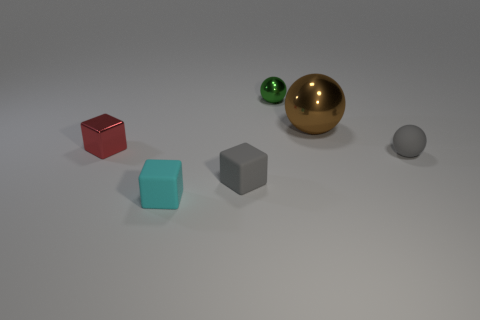Subtract all small cyan blocks. How many blocks are left? 2 Add 3 small gray blocks. How many objects exist? 9 Subtract 1 spheres. How many spheres are left? 2 Subtract all brown spheres. How many spheres are left? 2 Subtract all blue things. Subtract all green balls. How many objects are left? 5 Add 4 tiny cyan blocks. How many tiny cyan blocks are left? 5 Add 4 tiny gray spheres. How many tiny gray spheres exist? 5 Subtract 0 brown cubes. How many objects are left? 6 Subtract all yellow balls. Subtract all green cylinders. How many balls are left? 3 